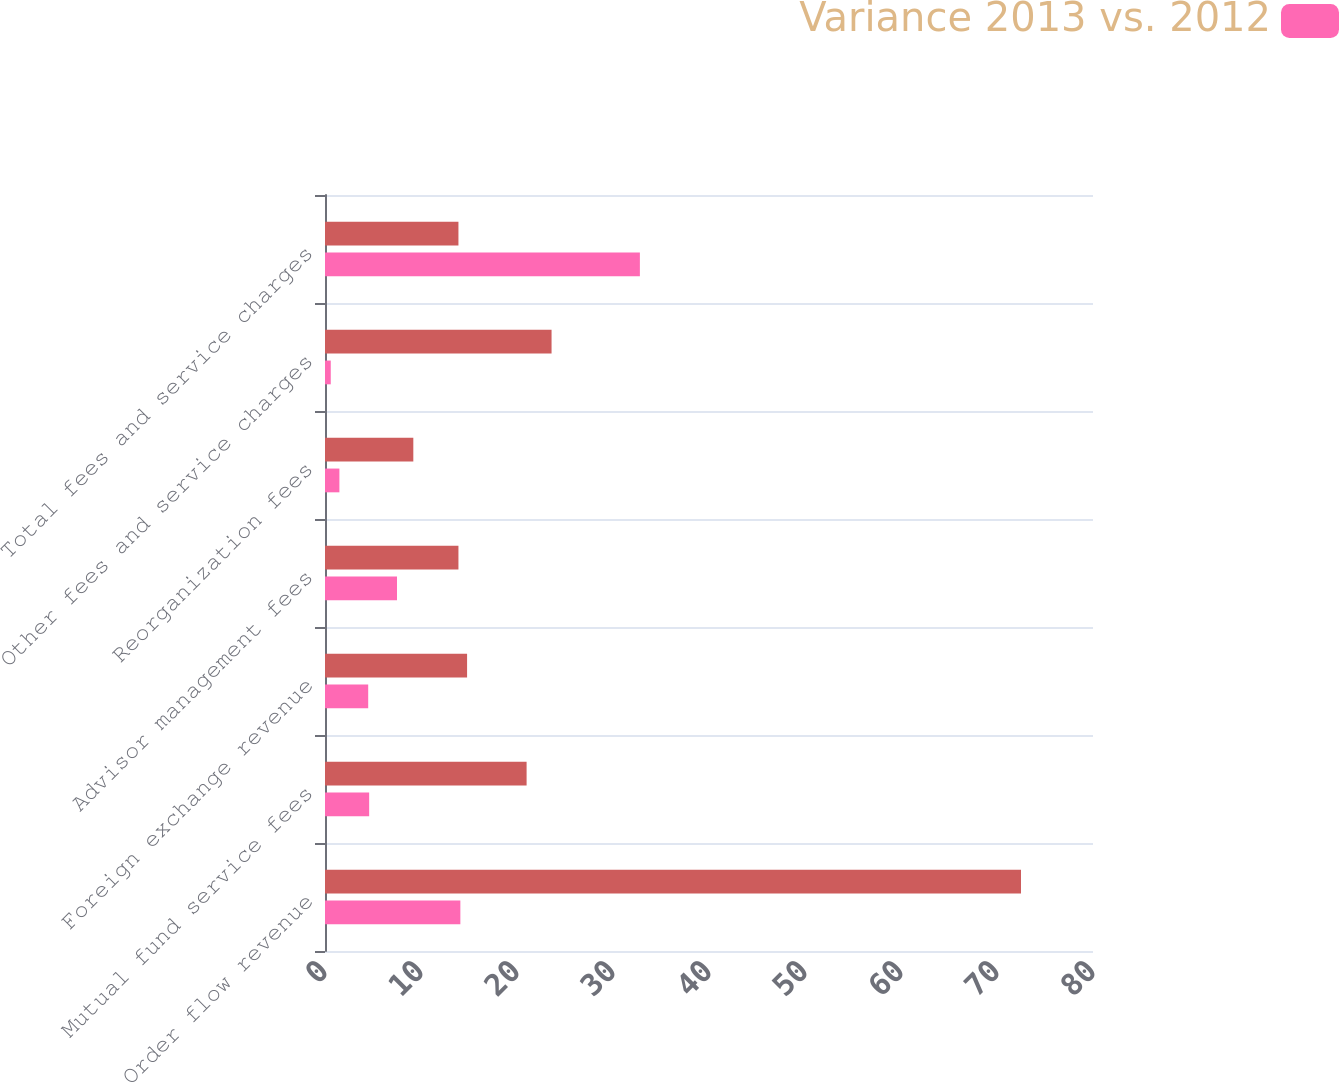Convert chart to OTSL. <chart><loc_0><loc_0><loc_500><loc_500><stacked_bar_chart><ecel><fcel>Order flow revenue<fcel>Mutual fund service fees<fcel>Foreign exchange revenue<fcel>Advisor management fees<fcel>Reorganization fees<fcel>Other fees and service charges<fcel>Total fees and service charges<nl><fcel>nan<fcel>72.5<fcel>21<fcel>14.8<fcel>13.9<fcel>9.2<fcel>23.6<fcel>13.9<nl><fcel>Variance 2013 vs. 2012<fcel>14.1<fcel>4.6<fcel>4.5<fcel>7.5<fcel>1.5<fcel>0.6<fcel>32.8<nl></chart> 